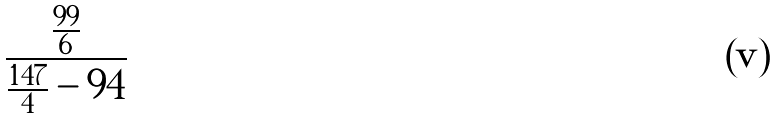Convert formula to latex. <formula><loc_0><loc_0><loc_500><loc_500>\frac { \frac { 9 9 } { 6 } } { \frac { 1 4 7 } { 4 } - 9 4 }</formula> 